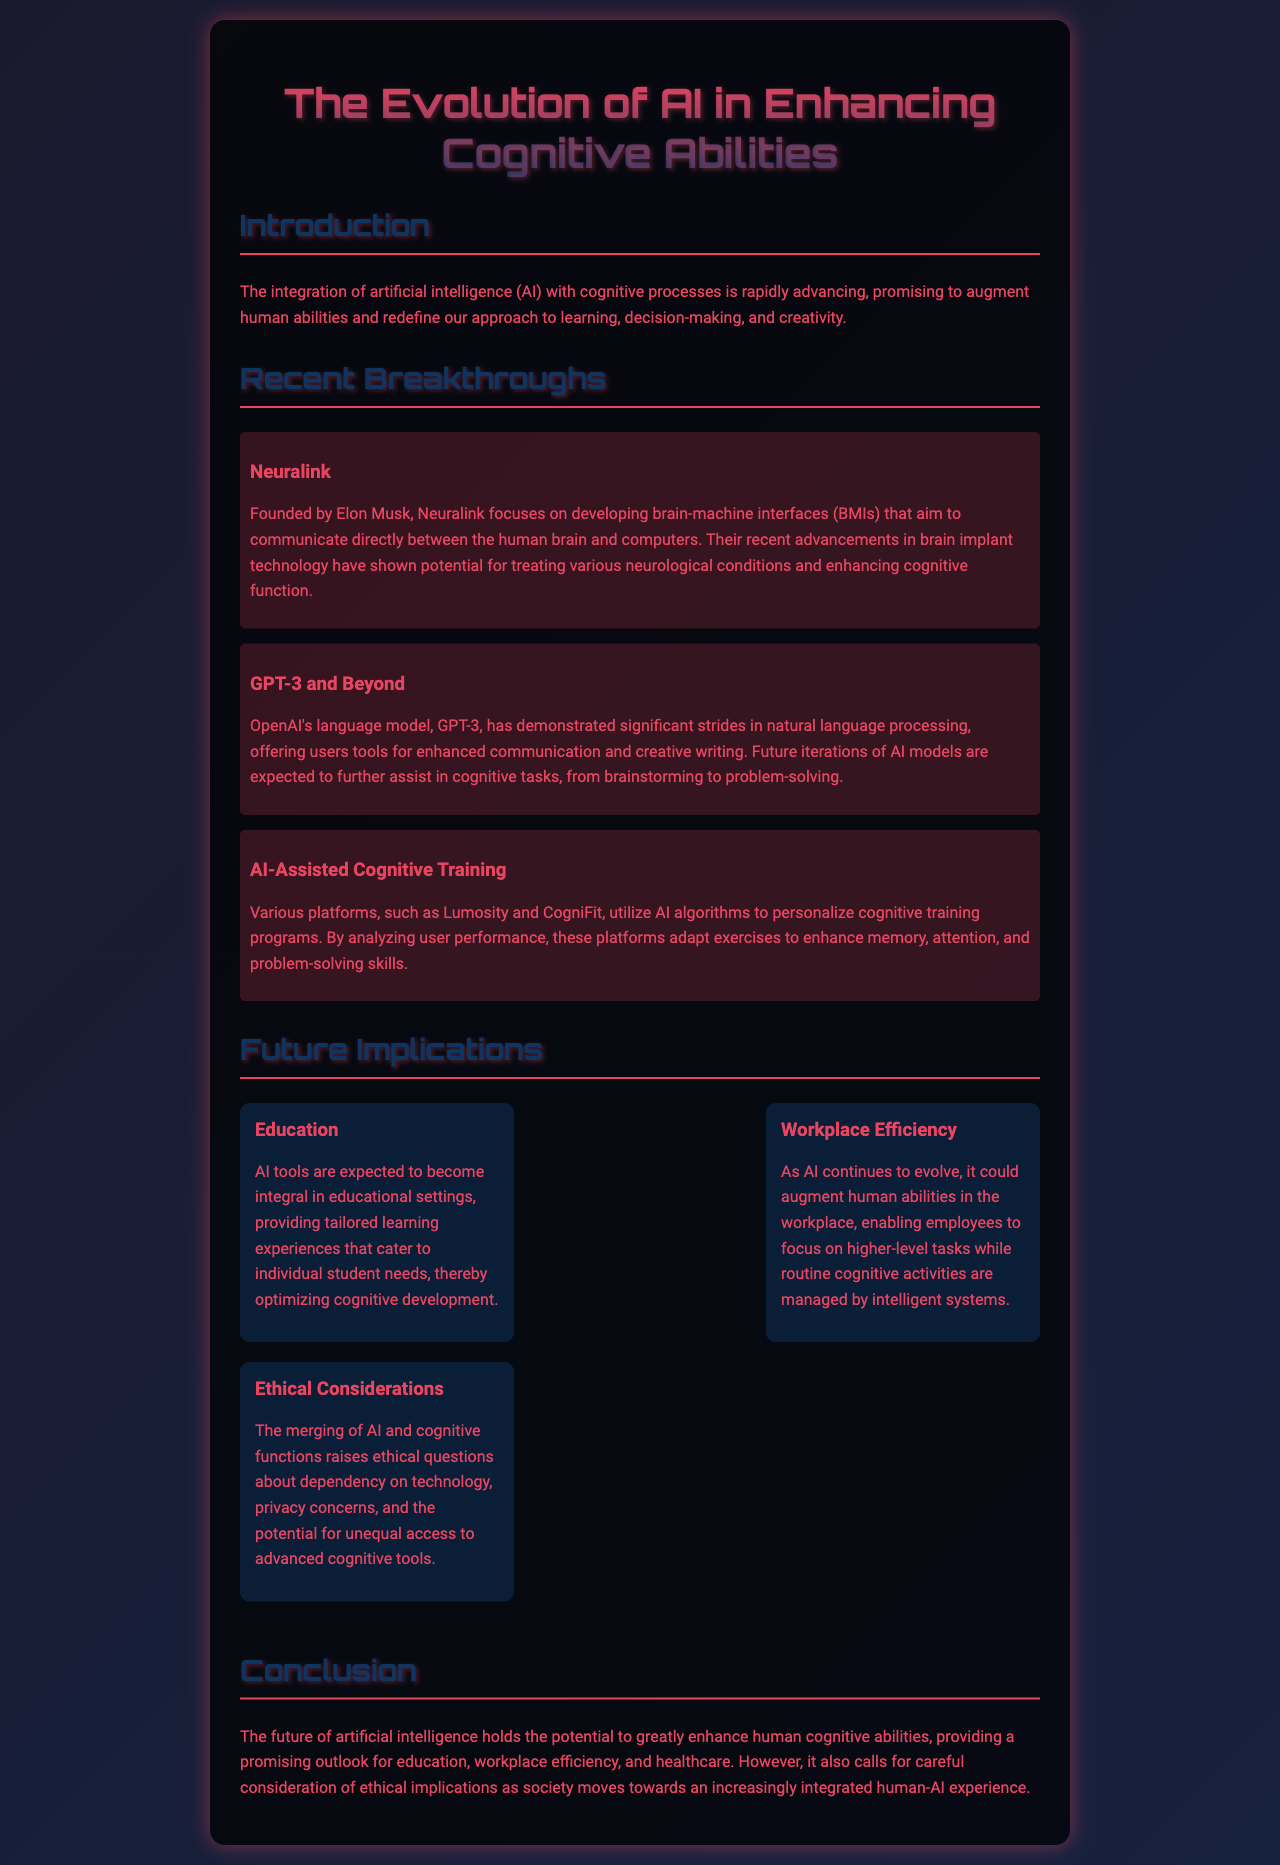What company is associated with Neuralink? Neuralink was founded by Elon Musk, who is a prominent figure in technology and innovation.
Answer: Elon Musk What model is mentioned as a significant advancement in natural language processing? The document highlights OpenAI's language model, known for its natural language processing capabilities.
Answer: GPT-3 Which platforms use AI algorithms for cognitive training? The report mentions specific platforms that employ AI to create personalized cognitive training programs.
Answer: Lumosity and CogniFit What is one expected outcome of AI in education? The document states that AI tools will provide tailored learning experiences to optimize cognitive development for students.
Answer: Tailored learning experiences What are two ethical considerations mentioned regarding AI and cognitive functions? The report highlights concerns related to dependency on technology and equal access to cognitive tools as important ethical considerations.
Answer: Dependency on technology and unequal access In what setting is AI expected to enhance workplace efficiency? The report discusses how AI will augment human abilities in professional environments, allowing workers to concentrate on higher-level tasks.
Answer: Workplace What type of technology does Neuralink focus on? The document describes specific technology that Neuralink specializes in to connect the human brain to machines.
Answer: Brain-machine interfaces What might AI provide to enhance human creativity? The advancements in AI are suggested to assist in creative tasks, increasing human creativity through improved tools and resources.
Answer: Enhanced communication and creative writing What overall impact does the document suggest AI will have on healthcare? The conclusion of the report hints at AI's potential to improve cognitive abilities, thereby impacting various sectors including healthcare.
Answer: Positive impact on cognitive abilities 